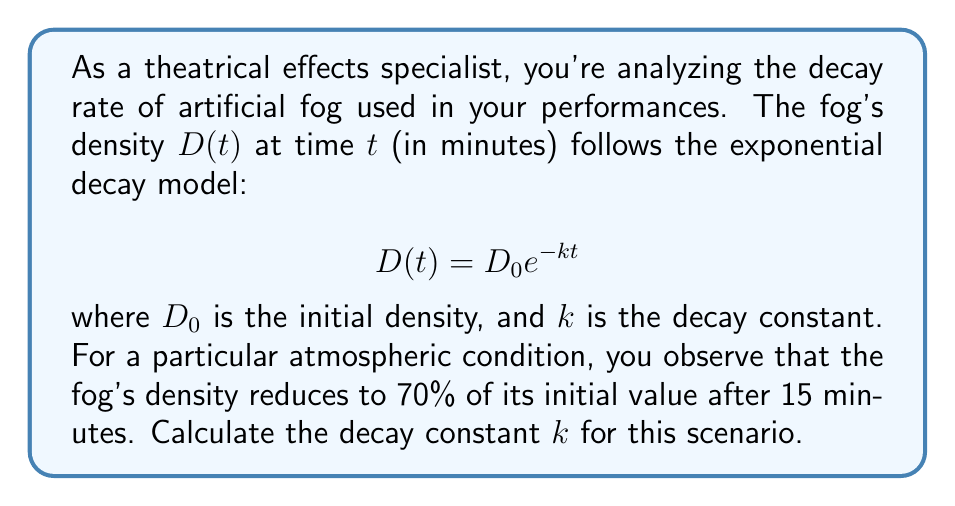What is the answer to this math problem? Let's approach this step-by-step:

1) We're given the exponential decay formula: $D(t) = D_0 e^{-kt}$

2) We know that after 15 minutes, the density is 70% of the initial density. Let's express this mathematically:

   $D(15) = 0.7D_0$

3) Substituting this into our original equation:

   $0.7D_0 = D_0 e^{-k(15)}$

4) We can divide both sides by $D_0$:

   $0.7 = e^{-15k}$

5) Now, let's take the natural logarithm of both sides:

   $\ln(0.7) = \ln(e^{-15k})$

6) The right side simplifies due to the properties of logarithms:

   $\ln(0.7) = -15k$

7) Now we can solve for $k$:

   $k = -\frac{\ln(0.7)}{15}$

8) Using a calculator or computer, we can evaluate this:

   $k \approx 0.0237$ min^(-1)

Thus, the decay constant $k$ is approximately 0.0237 min^(-1).
Answer: $k \approx 0.0237$ min^(-1) 